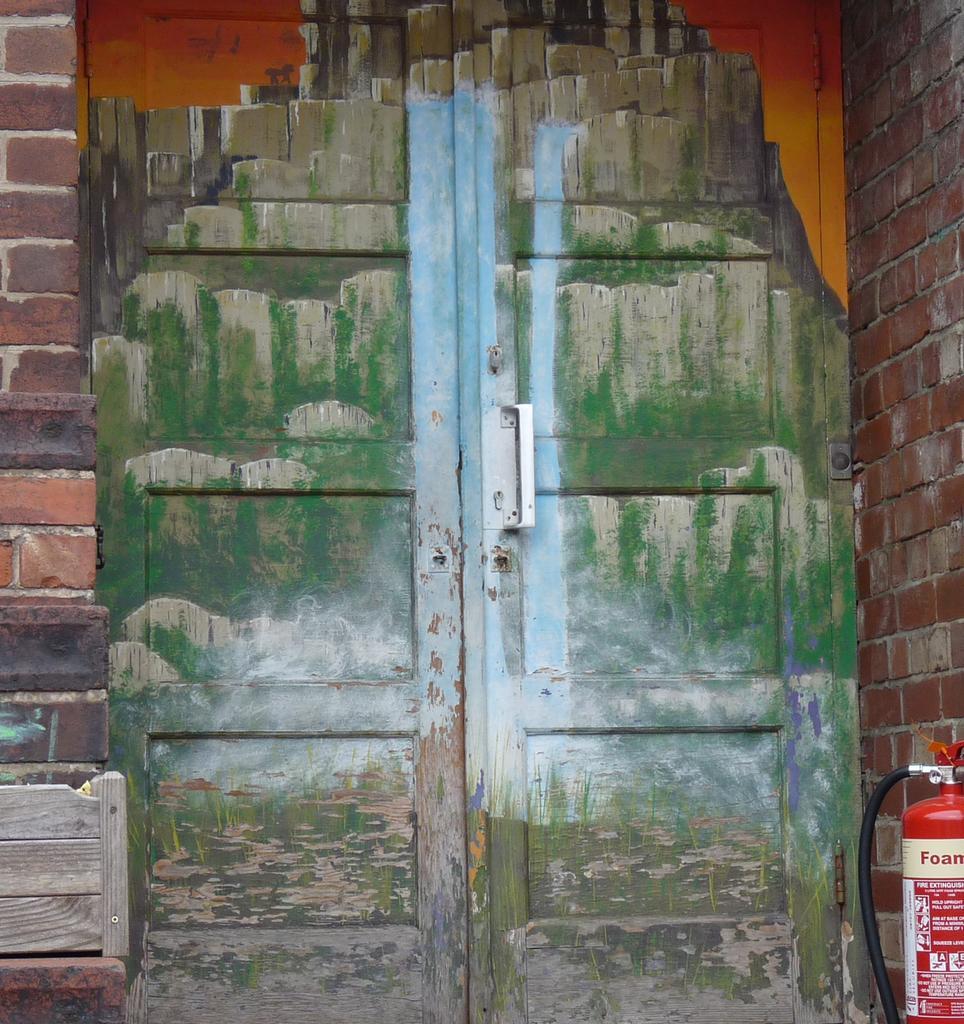Describe this image in one or two sentences. In this image there is a door to the wall. There are paintings on the door. In the bottom right there is a cylinder. There is text on the cylinder. 